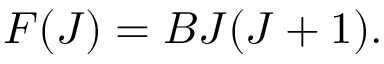Convert formula to latex. <formula><loc_0><loc_0><loc_500><loc_500>F ( J ) = B J ( J + 1 ) .</formula> 